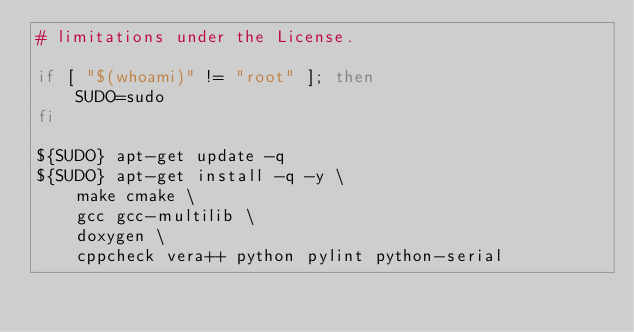Convert code to text. <code><loc_0><loc_0><loc_500><loc_500><_Bash_># limitations under the License.

if [ "$(whoami)" != "root" ]; then
    SUDO=sudo
fi

${SUDO} apt-get update -q
${SUDO} apt-get install -q -y \
    make cmake \
    gcc gcc-multilib \
    doxygen \
    cppcheck vera++ python pylint python-serial
</code> 